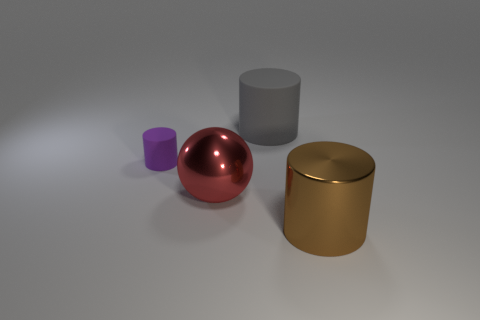What might be the purpose of arranging these objects in this way? This sort of arrangement could be part of a visual composition exercise, a study in 3D rendering techniques, or an illustration for a product display. The purpose can vary widely depending on the context in which the image is used. 